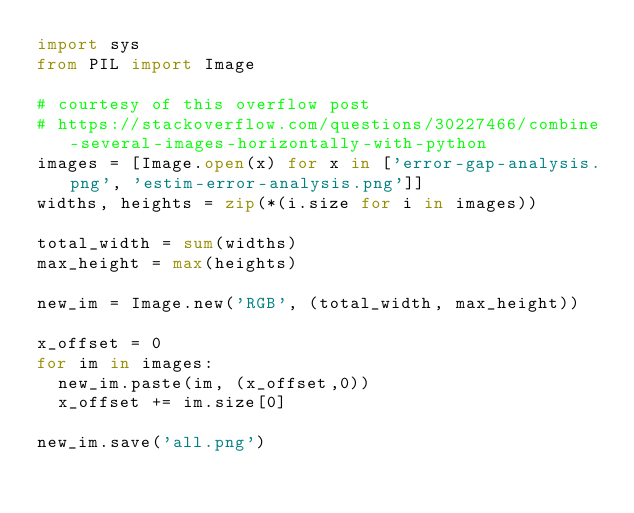<code> <loc_0><loc_0><loc_500><loc_500><_Python_>import sys
from PIL import Image

# courtesy of this overflow post
# https://stackoverflow.com/questions/30227466/combine-several-images-horizontally-with-python
images = [Image.open(x) for x in ['error-gap-analysis.png', 'estim-error-analysis.png']]
widths, heights = zip(*(i.size for i in images))

total_width = sum(widths)
max_height = max(heights)

new_im = Image.new('RGB', (total_width, max_height))

x_offset = 0
for im in images:
  new_im.paste(im, (x_offset,0))
  x_offset += im.size[0]

new_im.save('all.png')</code> 